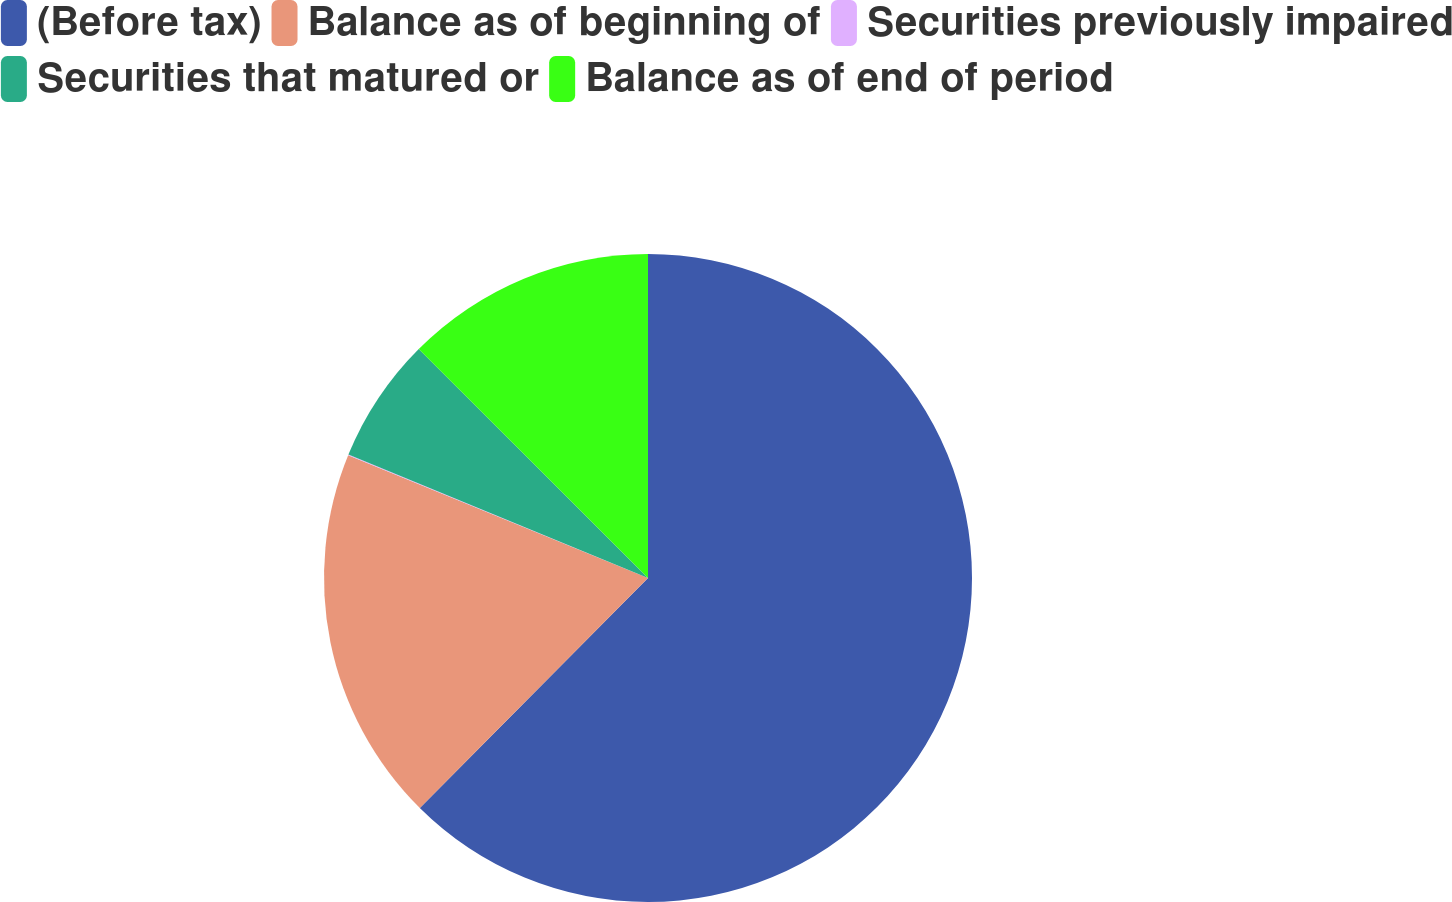Convert chart. <chart><loc_0><loc_0><loc_500><loc_500><pie_chart><fcel>(Before tax)<fcel>Balance as of beginning of<fcel>Securities previously impaired<fcel>Securities that matured or<fcel>Balance as of end of period<nl><fcel>62.43%<fcel>18.75%<fcel>0.03%<fcel>6.27%<fcel>12.51%<nl></chart> 